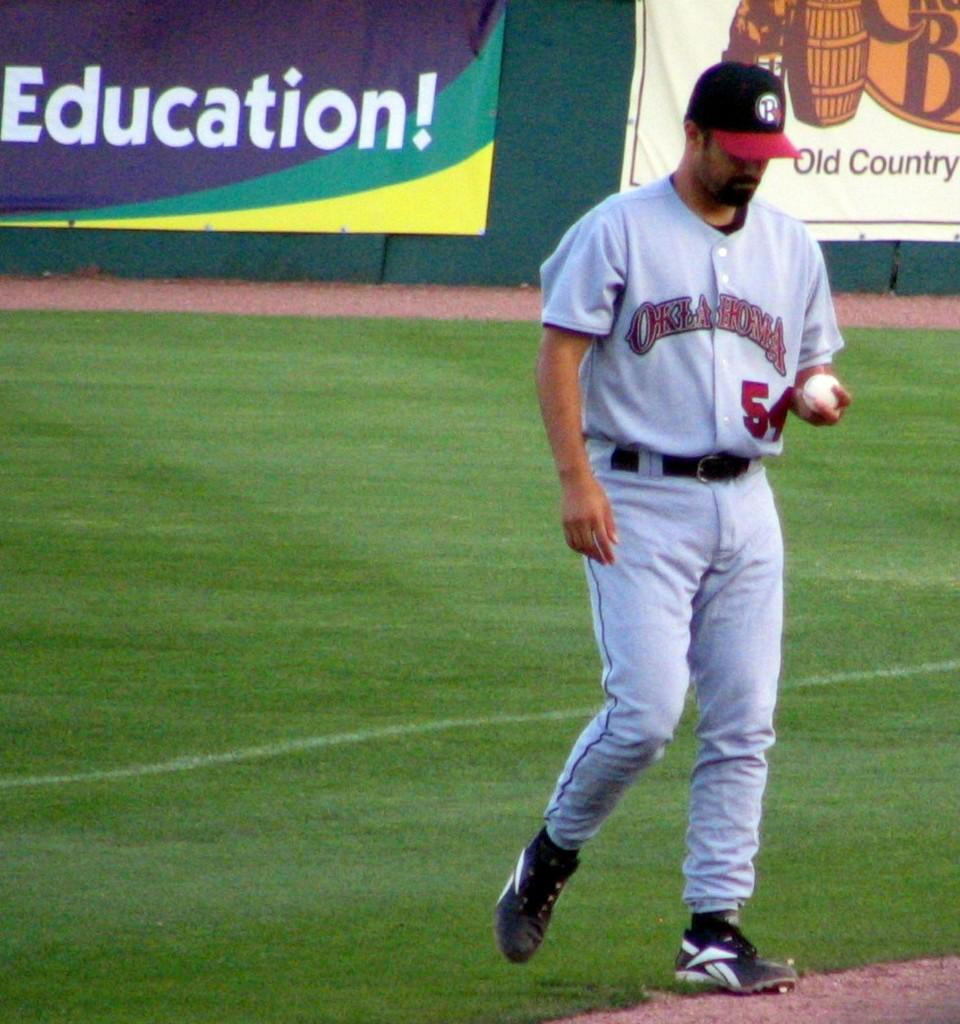<image>
Write a terse but informative summary of the picture. Player number 54 for Oklahoma holds a baseball during a game. 